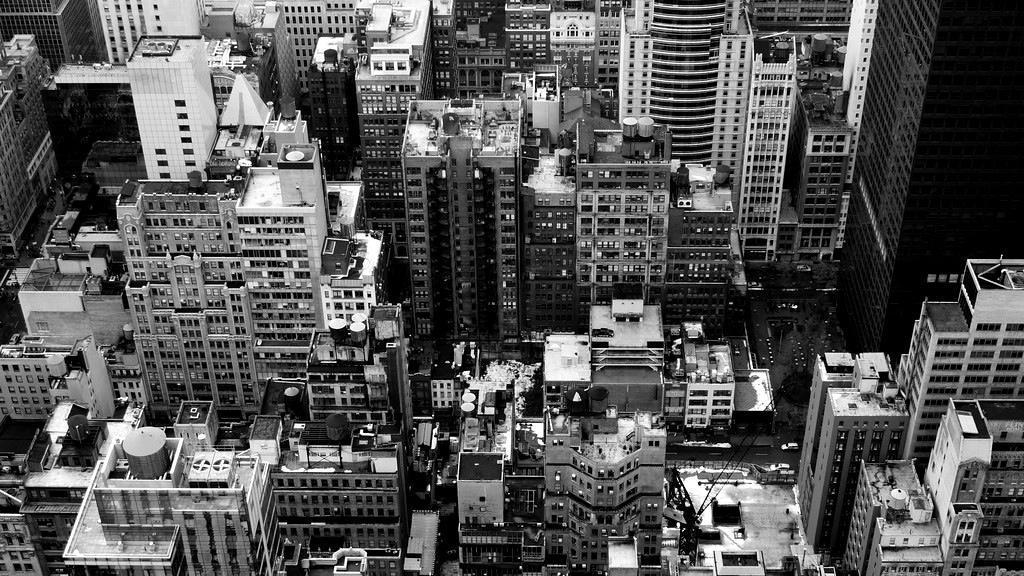Can you describe this image briefly? In this picture we can see a group of buildings. 